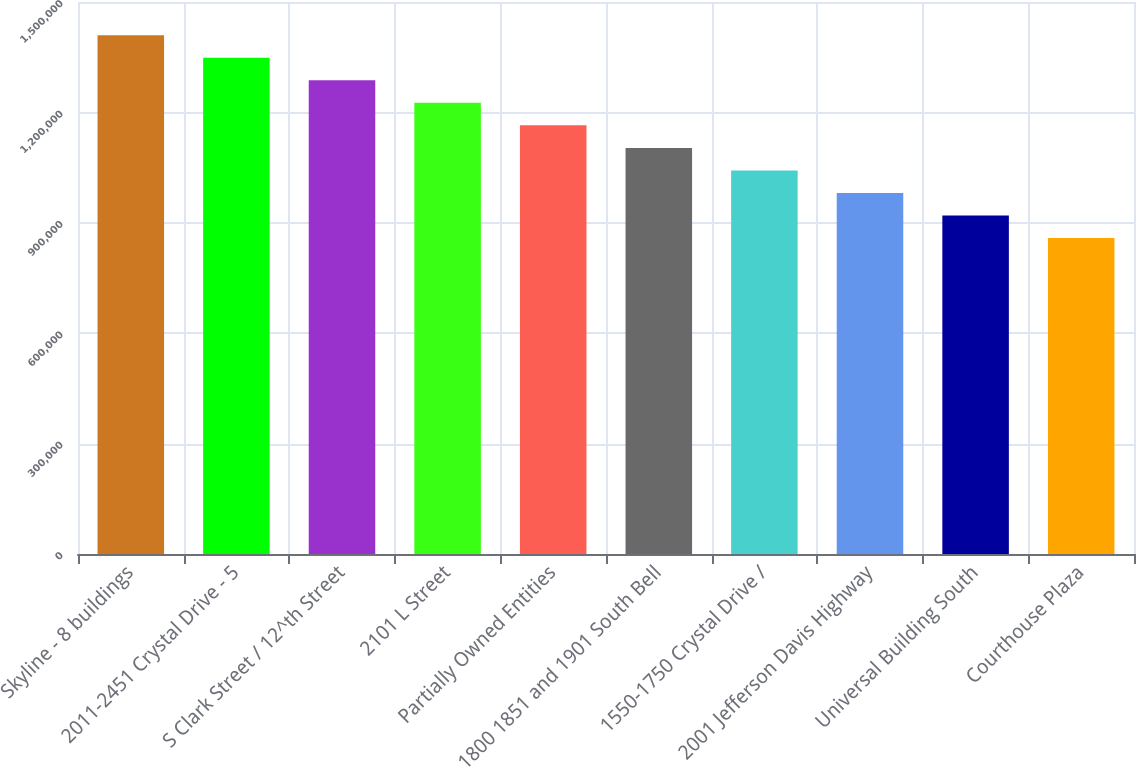Convert chart to OTSL. <chart><loc_0><loc_0><loc_500><loc_500><bar_chart><fcel>Skyline - 8 buildings<fcel>2011-2451 Crystal Drive - 5<fcel>S Clark Street / 12^th Street<fcel>2101 L Street<fcel>Partially Owned Entities<fcel>1800 1851 and 1901 South Bell<fcel>1550-1750 Crystal Drive /<fcel>2001 Jefferson Davis Highway<fcel>Universal Building South<fcel>Courthouse Plaza<nl><fcel>1.4096e+06<fcel>1.3484e+06<fcel>1.2872e+06<fcel>1.226e+06<fcel>1.1648e+06<fcel>1.1036e+06<fcel>1.0424e+06<fcel>981200<fcel>920000<fcel>858800<nl></chart> 